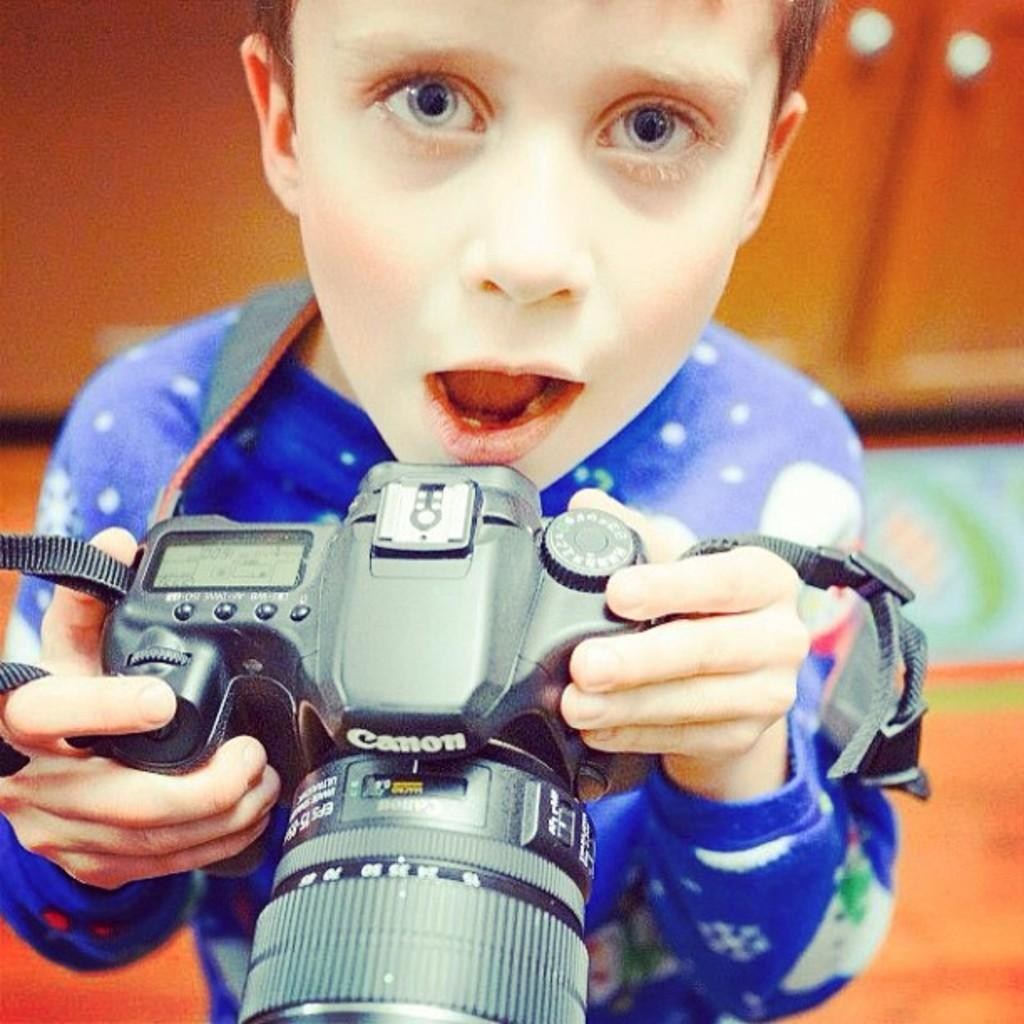What is the main subject of the image? The main subject of the image is a boy. What is the boy holding in his hand? The boy is holding a camera in his hand. What color is the t-shirt the boy is wearing? The boy is wearing a blue color t-shirt. What type of sack is the boy carrying on his back in the image? There is no sack visible in the image; the boy is only holding a camera in his hand. 